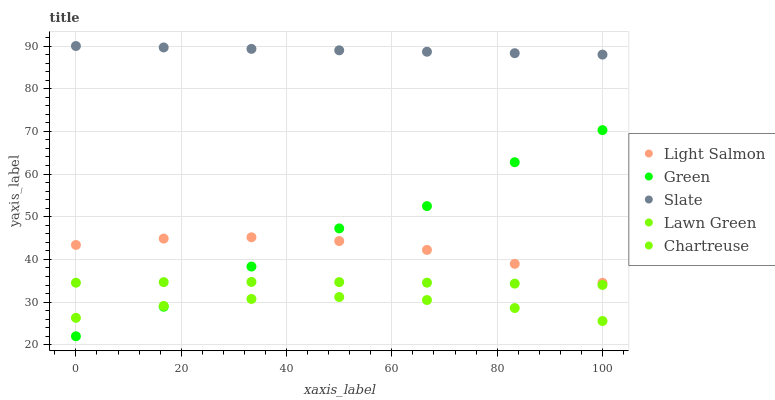Does Chartreuse have the minimum area under the curve?
Answer yes or no. Yes. Does Slate have the maximum area under the curve?
Answer yes or no. Yes. Does Light Salmon have the minimum area under the curve?
Answer yes or no. No. Does Light Salmon have the maximum area under the curve?
Answer yes or no. No. Is Slate the smoothest?
Answer yes or no. Yes. Is Green the roughest?
Answer yes or no. Yes. Is Light Salmon the smoothest?
Answer yes or no. No. Is Light Salmon the roughest?
Answer yes or no. No. Does Green have the lowest value?
Answer yes or no. Yes. Does Light Salmon have the lowest value?
Answer yes or no. No. Does Slate have the highest value?
Answer yes or no. Yes. Does Light Salmon have the highest value?
Answer yes or no. No. Is Green less than Slate?
Answer yes or no. Yes. Is Light Salmon greater than Chartreuse?
Answer yes or no. Yes. Does Green intersect Light Salmon?
Answer yes or no. Yes. Is Green less than Light Salmon?
Answer yes or no. No. Is Green greater than Light Salmon?
Answer yes or no. No. Does Green intersect Slate?
Answer yes or no. No. 